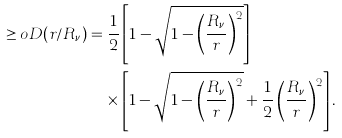Convert formula to latex. <formula><loc_0><loc_0><loc_500><loc_500>\geq o D ( r / R _ { \nu } ) & = \frac { 1 } { 2 } \left [ 1 - \sqrt { 1 - \left ( \frac { R _ { \nu } } { r } \right ) ^ { 2 } } \right ] \\ & \quad \times \left [ 1 - \sqrt { 1 - \left ( \frac { R _ { \nu } } { r } \right ) ^ { 2 } } + \frac { 1 } { 2 } \left ( \frac { R _ { \nu } } { r } \right ) ^ { 2 } \right ] .</formula> 